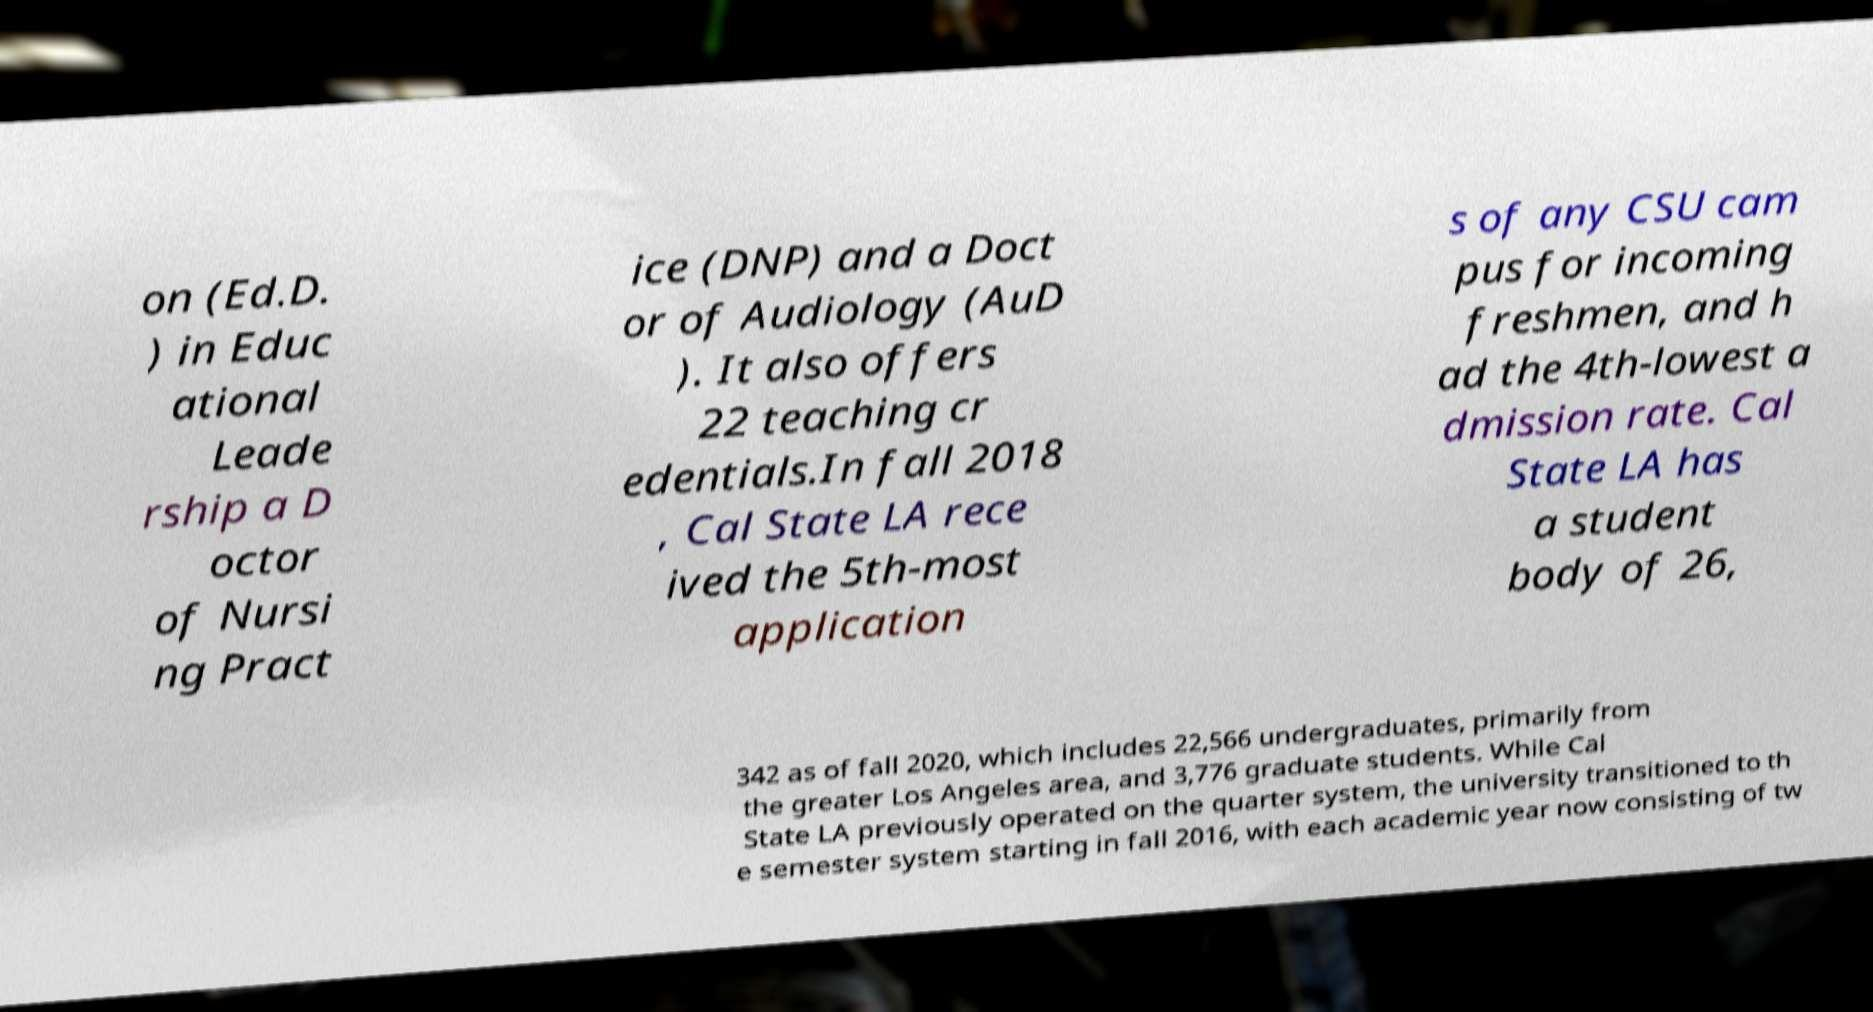What messages or text are displayed in this image? I need them in a readable, typed format. on (Ed.D. ) in Educ ational Leade rship a D octor of Nursi ng Pract ice (DNP) and a Doct or of Audiology (AuD ). It also offers 22 teaching cr edentials.In fall 2018 , Cal State LA rece ived the 5th-most application s of any CSU cam pus for incoming freshmen, and h ad the 4th-lowest a dmission rate. Cal State LA has a student body of 26, 342 as of fall 2020, which includes 22,566 undergraduates, primarily from the greater Los Angeles area, and 3,776 graduate students. While Cal State LA previously operated on the quarter system, the university transitioned to th e semester system starting in fall 2016, with each academic year now consisting of tw 